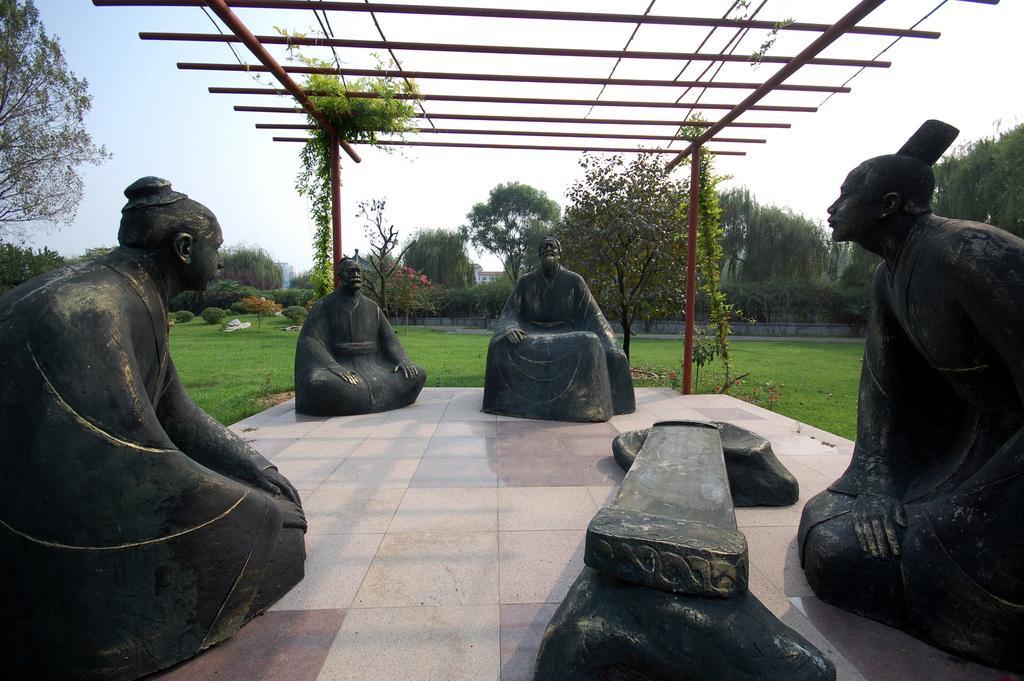In one or two sentences, can you explain what this image depicts? In this picture, there are four men statues on the floor which are made up of stone. On the top, there are iron rods with supporting rods. In the background, there is a garden with grass, trees, flowers etc. 